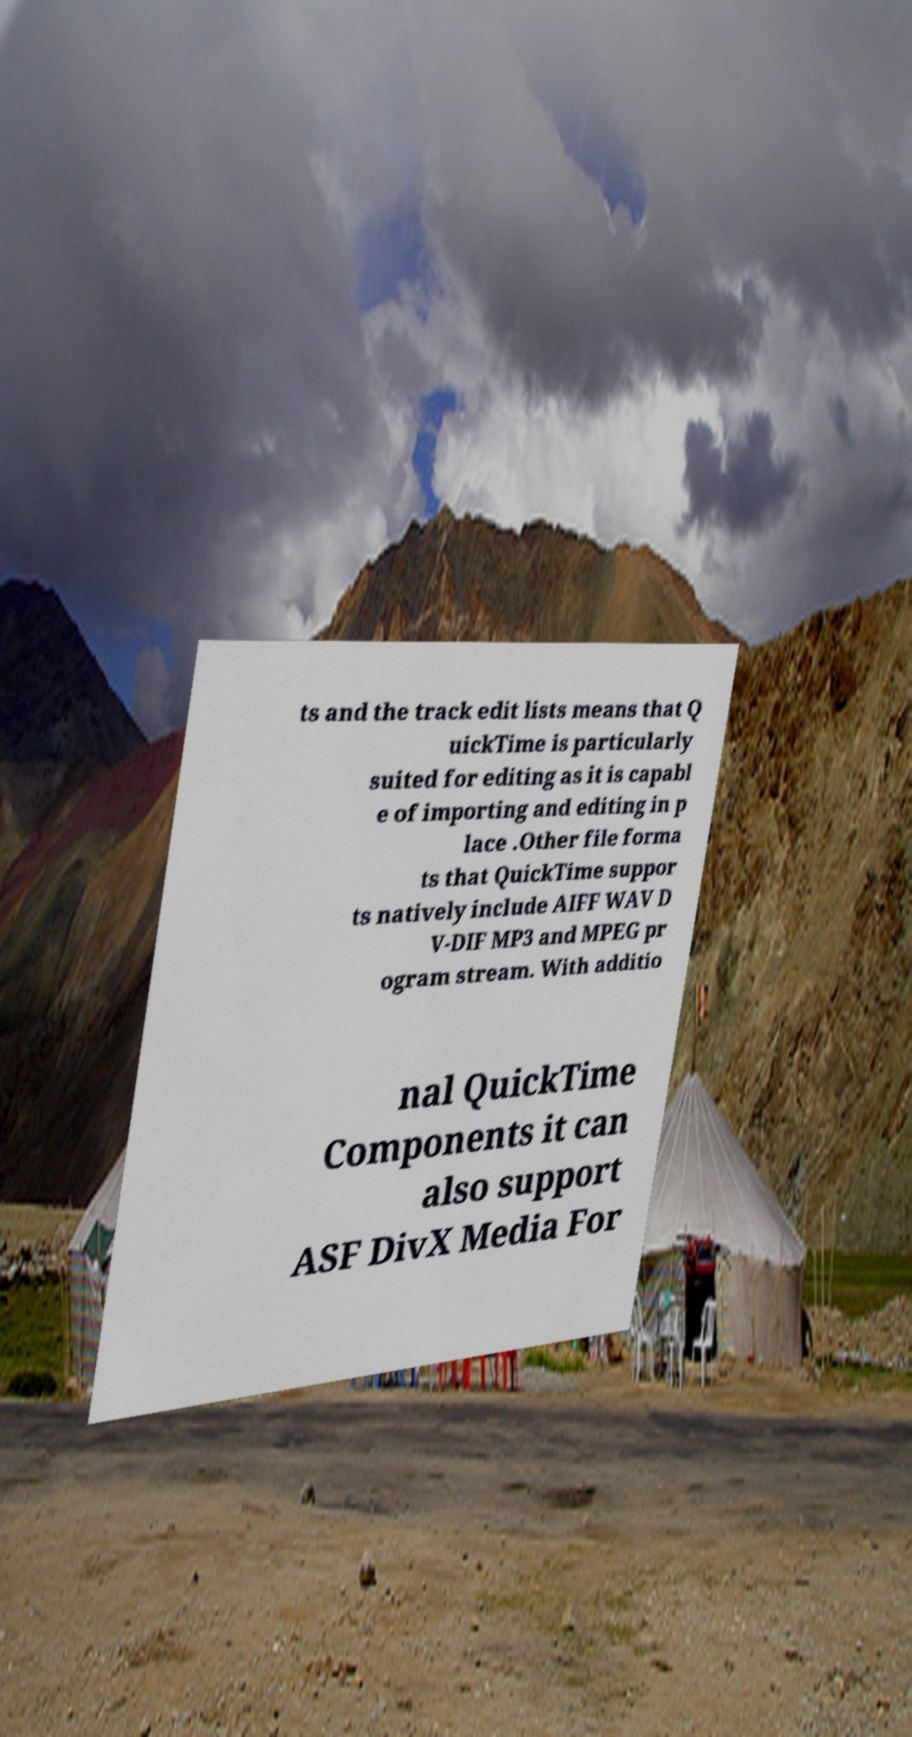Can you accurately transcribe the text from the provided image for me? ts and the track edit lists means that Q uickTime is particularly suited for editing as it is capabl e of importing and editing in p lace .Other file forma ts that QuickTime suppor ts natively include AIFF WAV D V-DIF MP3 and MPEG pr ogram stream. With additio nal QuickTime Components it can also support ASF DivX Media For 